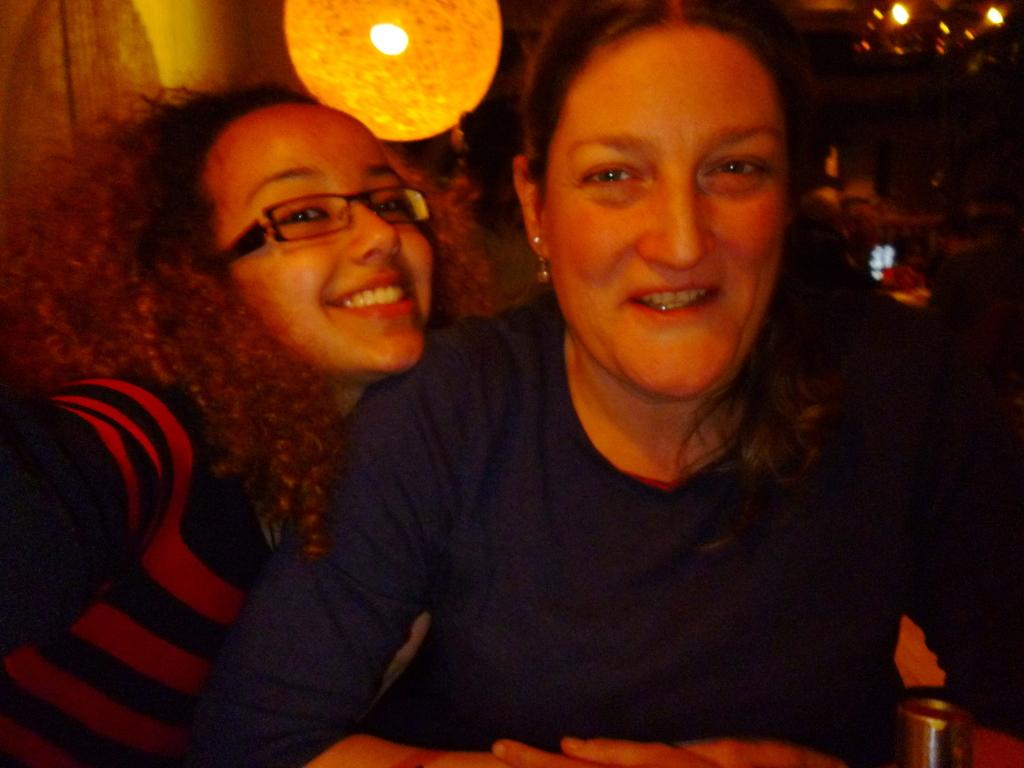How many people are in the image? There are two people in the image. What is the facial expression of the people in the image? Both people are smiling. What can be observed about the clothing of the people in the image? The people are wearing different color dresses. What can be seen in the background of the image? There are lights visible in the background. How would you describe the overall lighting in the image? The background of the image is dark. What type of paper is being used in the game depicted in the image? There is no game or paper present in the image; it features two people smiling and wearing different color dresses. 